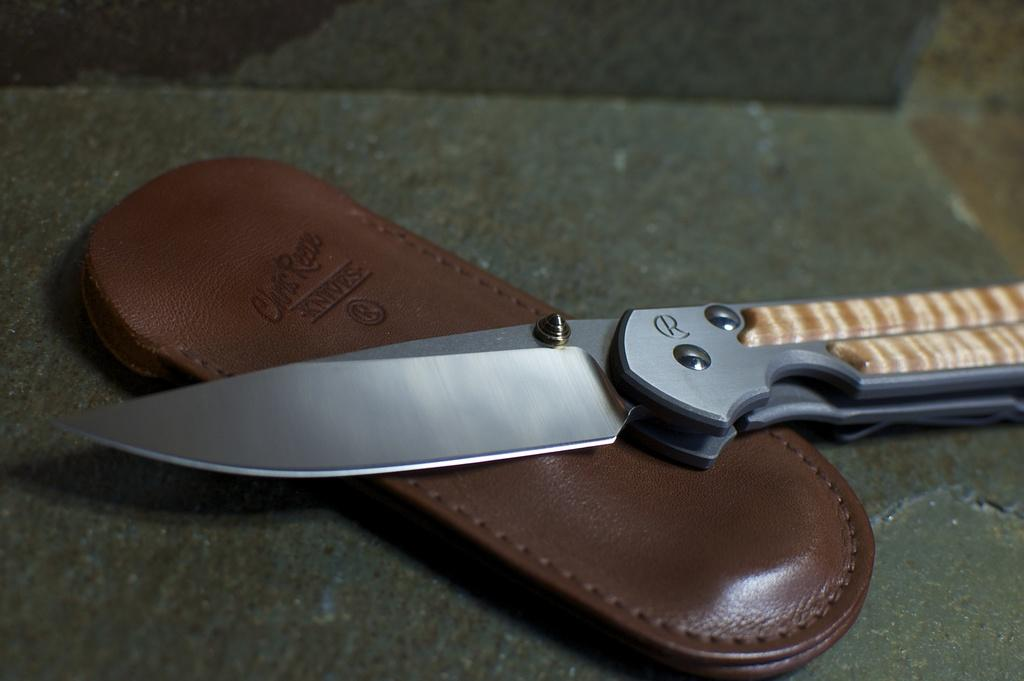What type of utensil is present in the image? There is a knife in the image. What material is used to make the object in the image? The object in the image is made of leather. How many frogs are sitting in the soup in the image? There are no frogs or soup present in the image. What type of eggs are being used to make the leather object in the image? There are no eggs involved in the creation of the leather object in the image. 